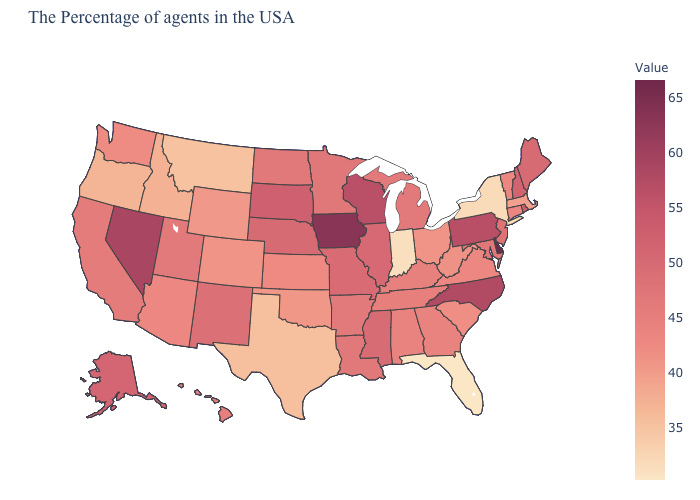Is the legend a continuous bar?
Give a very brief answer. Yes. Which states hav the highest value in the Northeast?
Write a very short answer. Pennsylvania. Which states have the lowest value in the USA?
Be succinct. Florida. Among the states that border Kentucky , which have the lowest value?
Be succinct. Indiana. Which states have the highest value in the USA?
Concise answer only. Delaware. 